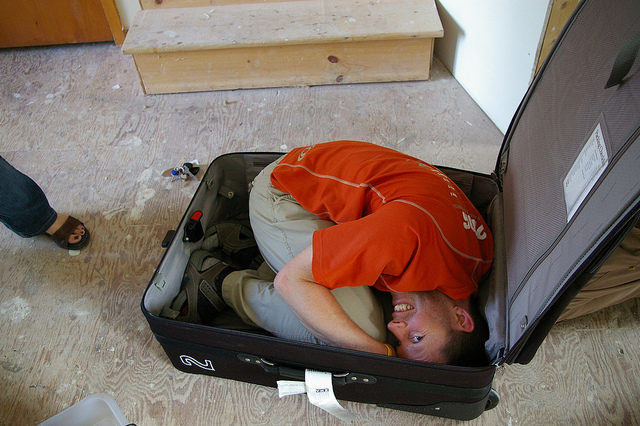<image>How many cubic inches is that suitcase? It is unknown how many cubic inches the suitcase is. How many cubic inches is that suitcase? I don't know how many cubic inches is that suitcase. It can be any of the given options. 